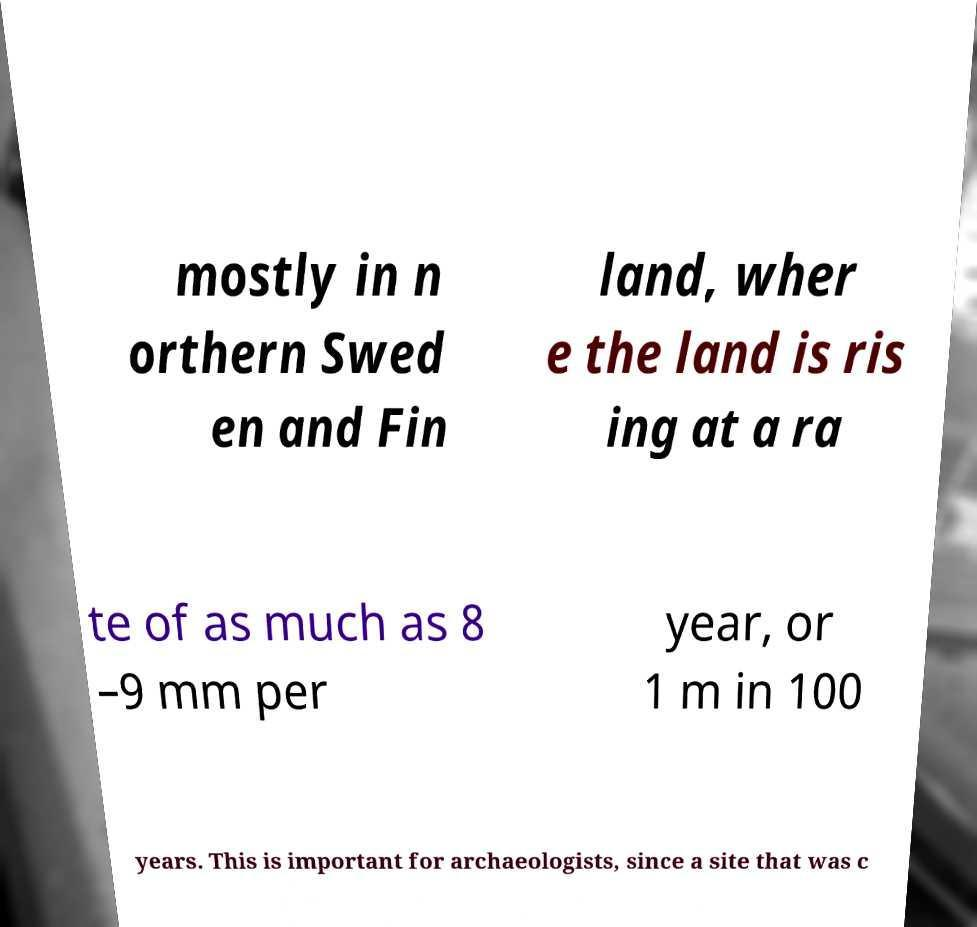I need the written content from this picture converted into text. Can you do that? mostly in n orthern Swed en and Fin land, wher e the land is ris ing at a ra te of as much as 8 –9 mm per year, or 1 m in 100 years. This is important for archaeologists, since a site that was c 